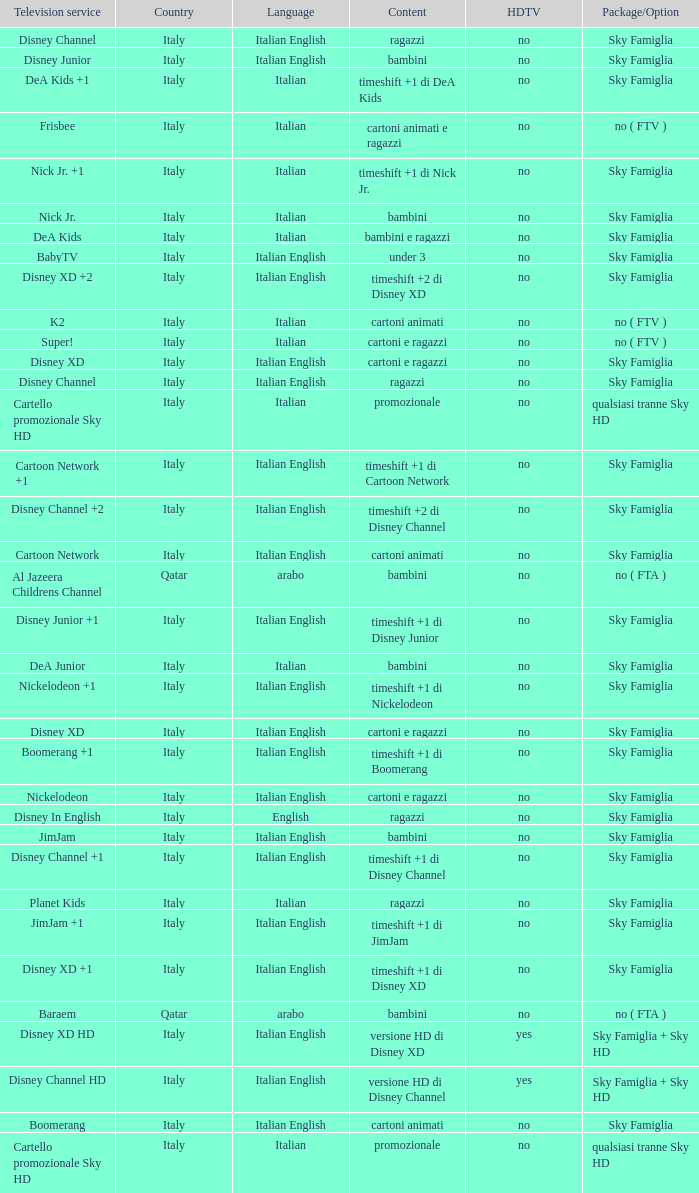What shows as Content for the Television service of nickelodeon +1? Timeshift +1 di nickelodeon. 